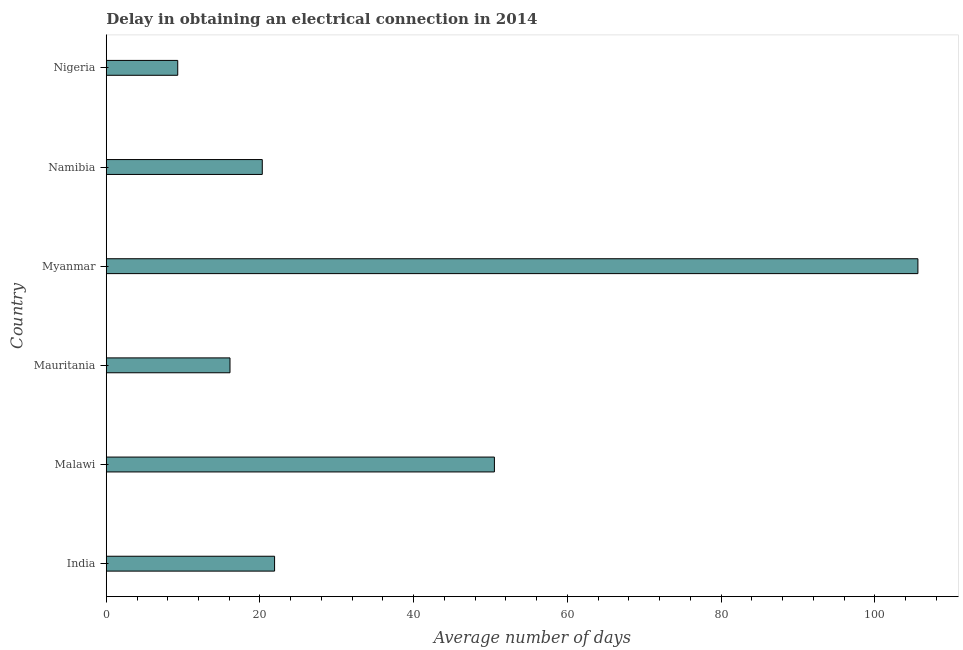Does the graph contain any zero values?
Provide a succinct answer. No. What is the title of the graph?
Offer a very short reply. Delay in obtaining an electrical connection in 2014. What is the label or title of the X-axis?
Provide a short and direct response. Average number of days. What is the dalay in electrical connection in Malawi?
Your answer should be compact. 50.5. Across all countries, what is the maximum dalay in electrical connection?
Offer a very short reply. 105.6. In which country was the dalay in electrical connection maximum?
Make the answer very short. Myanmar. In which country was the dalay in electrical connection minimum?
Make the answer very short. Nigeria. What is the sum of the dalay in electrical connection?
Keep it short and to the point. 223.7. What is the difference between the dalay in electrical connection in India and Malawi?
Your answer should be compact. -28.6. What is the average dalay in electrical connection per country?
Offer a terse response. 37.28. What is the median dalay in electrical connection?
Ensure brevity in your answer.  21.1. What is the ratio of the dalay in electrical connection in Mauritania to that in Myanmar?
Your answer should be compact. 0.15. What is the difference between the highest and the second highest dalay in electrical connection?
Provide a succinct answer. 55.1. What is the difference between the highest and the lowest dalay in electrical connection?
Provide a short and direct response. 96.3. How many countries are there in the graph?
Give a very brief answer. 6. What is the difference between two consecutive major ticks on the X-axis?
Ensure brevity in your answer.  20. What is the Average number of days in India?
Your response must be concise. 21.9. What is the Average number of days of Malawi?
Your answer should be very brief. 50.5. What is the Average number of days in Mauritania?
Offer a very short reply. 16.1. What is the Average number of days of Myanmar?
Ensure brevity in your answer.  105.6. What is the Average number of days of Namibia?
Give a very brief answer. 20.3. What is the Average number of days of Nigeria?
Keep it short and to the point. 9.3. What is the difference between the Average number of days in India and Malawi?
Offer a very short reply. -28.6. What is the difference between the Average number of days in India and Mauritania?
Provide a short and direct response. 5.8. What is the difference between the Average number of days in India and Myanmar?
Ensure brevity in your answer.  -83.7. What is the difference between the Average number of days in India and Namibia?
Your response must be concise. 1.6. What is the difference between the Average number of days in India and Nigeria?
Make the answer very short. 12.6. What is the difference between the Average number of days in Malawi and Mauritania?
Offer a terse response. 34.4. What is the difference between the Average number of days in Malawi and Myanmar?
Offer a very short reply. -55.1. What is the difference between the Average number of days in Malawi and Namibia?
Offer a terse response. 30.2. What is the difference between the Average number of days in Malawi and Nigeria?
Provide a succinct answer. 41.2. What is the difference between the Average number of days in Mauritania and Myanmar?
Make the answer very short. -89.5. What is the difference between the Average number of days in Myanmar and Namibia?
Give a very brief answer. 85.3. What is the difference between the Average number of days in Myanmar and Nigeria?
Your response must be concise. 96.3. What is the ratio of the Average number of days in India to that in Malawi?
Provide a short and direct response. 0.43. What is the ratio of the Average number of days in India to that in Mauritania?
Your answer should be very brief. 1.36. What is the ratio of the Average number of days in India to that in Myanmar?
Your response must be concise. 0.21. What is the ratio of the Average number of days in India to that in Namibia?
Offer a terse response. 1.08. What is the ratio of the Average number of days in India to that in Nigeria?
Offer a very short reply. 2.35. What is the ratio of the Average number of days in Malawi to that in Mauritania?
Provide a succinct answer. 3.14. What is the ratio of the Average number of days in Malawi to that in Myanmar?
Offer a very short reply. 0.48. What is the ratio of the Average number of days in Malawi to that in Namibia?
Provide a succinct answer. 2.49. What is the ratio of the Average number of days in Malawi to that in Nigeria?
Make the answer very short. 5.43. What is the ratio of the Average number of days in Mauritania to that in Myanmar?
Offer a terse response. 0.15. What is the ratio of the Average number of days in Mauritania to that in Namibia?
Provide a succinct answer. 0.79. What is the ratio of the Average number of days in Mauritania to that in Nigeria?
Your response must be concise. 1.73. What is the ratio of the Average number of days in Myanmar to that in Namibia?
Your response must be concise. 5.2. What is the ratio of the Average number of days in Myanmar to that in Nigeria?
Your answer should be very brief. 11.36. What is the ratio of the Average number of days in Namibia to that in Nigeria?
Offer a terse response. 2.18. 